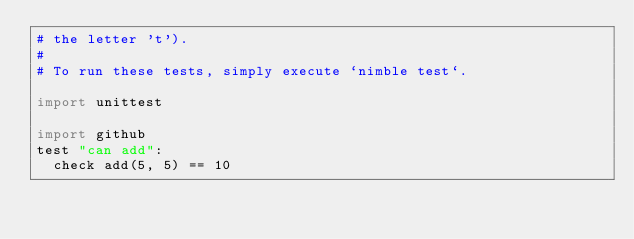<code> <loc_0><loc_0><loc_500><loc_500><_Nim_># the letter 't').
#
# To run these tests, simply execute `nimble test`.

import unittest

import github
test "can add":
  check add(5, 5) == 10
</code> 